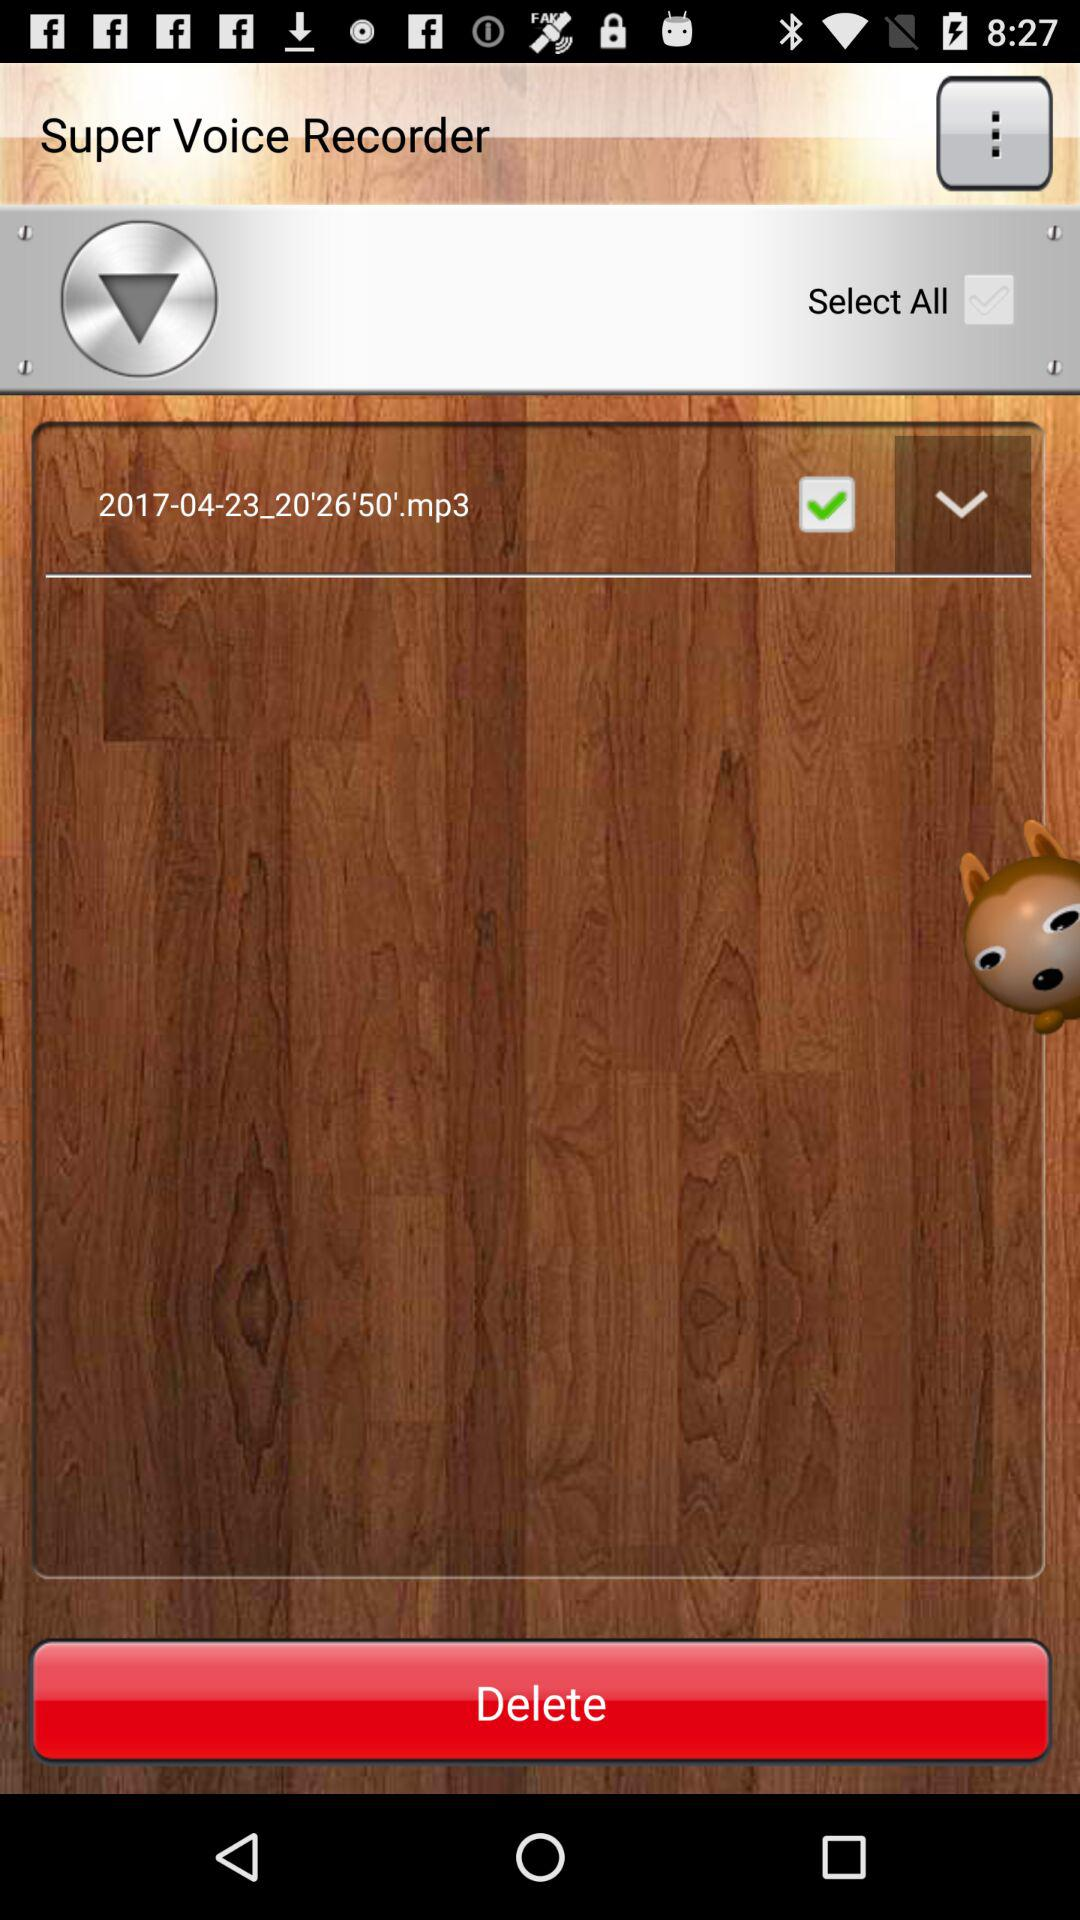What is the app name? The app name is "Super Voice Recorder". 